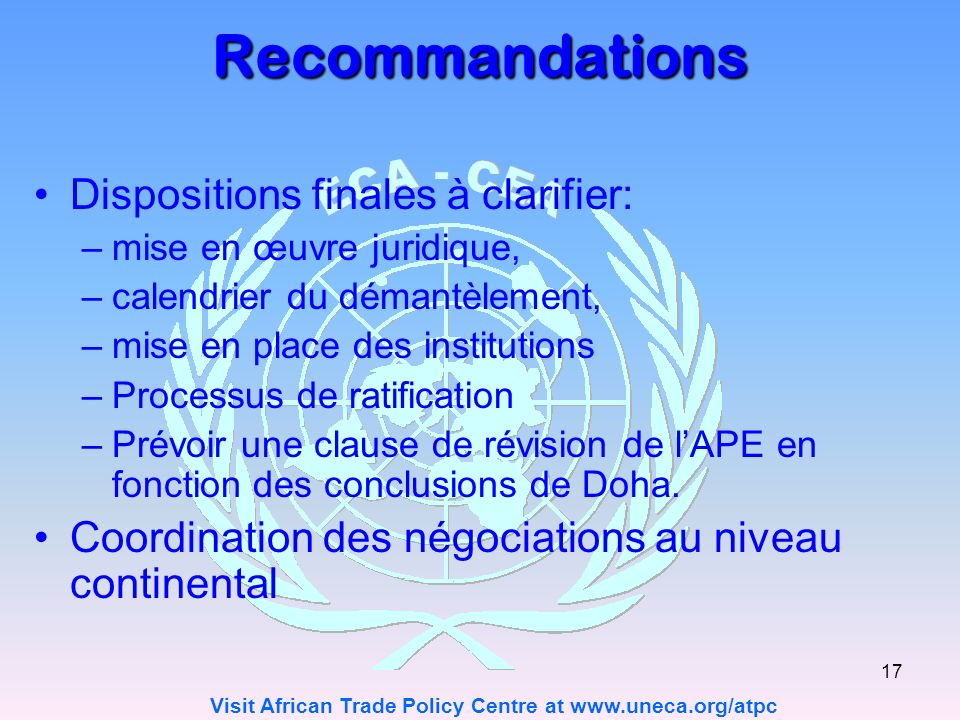Can you describe the key elements in the image related to the final provisions that need clarity? The image lists several key elements under final provisions that need clarity: juridical implementation, a disassembly schedule, the establishment of institutions, and the ratification process. Each of these points involves detailed planning and careful execution to ensure that the terms of any economic partnership agreement are both effective and equitable. Clarifying these elements would likely involve setting out detailed guidelines on how to legally enact the agreement's terms, timeline settings for gradual integration or disassembly of trade barriers, and establishing the necessary institutional frameworks to support the mechanisms of the agreement. 